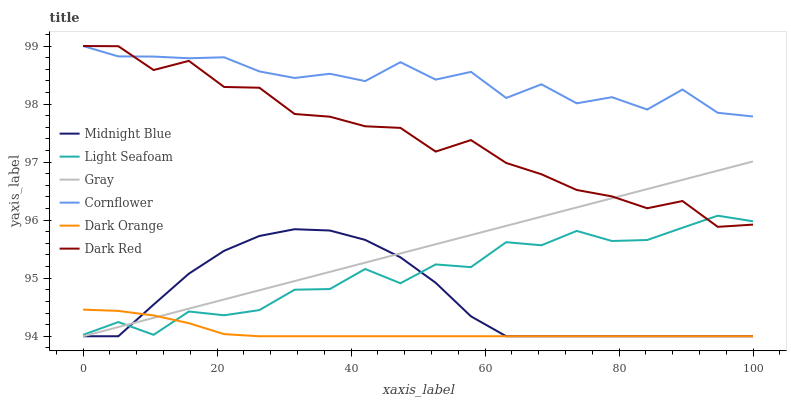Does Dark Orange have the minimum area under the curve?
Answer yes or no. Yes. Does Cornflower have the maximum area under the curve?
Answer yes or no. Yes. Does Midnight Blue have the minimum area under the curve?
Answer yes or no. No. Does Midnight Blue have the maximum area under the curve?
Answer yes or no. No. Is Gray the smoothest?
Answer yes or no. Yes. Is Cornflower the roughest?
Answer yes or no. Yes. Is Midnight Blue the smoothest?
Answer yes or no. No. Is Midnight Blue the roughest?
Answer yes or no. No. Does Dark Orange have the lowest value?
Answer yes or no. Yes. Does Dark Red have the lowest value?
Answer yes or no. No. Does Cornflower have the highest value?
Answer yes or no. Yes. Does Midnight Blue have the highest value?
Answer yes or no. No. Is Dark Orange less than Cornflower?
Answer yes or no. Yes. Is Cornflower greater than Light Seafoam?
Answer yes or no. Yes. Does Dark Orange intersect Gray?
Answer yes or no. Yes. Is Dark Orange less than Gray?
Answer yes or no. No. Is Dark Orange greater than Gray?
Answer yes or no. No. Does Dark Orange intersect Cornflower?
Answer yes or no. No. 